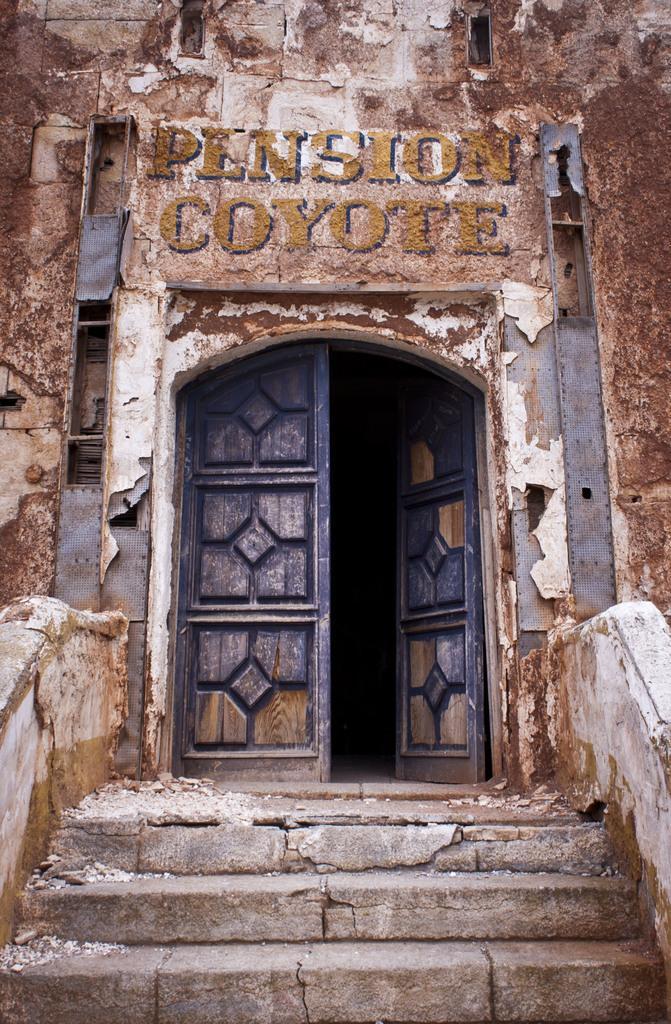Describe this image in one or two sentences. In this picture there is a building and there is text on the wall. In the foreground and there is a door and there is a staircase. 